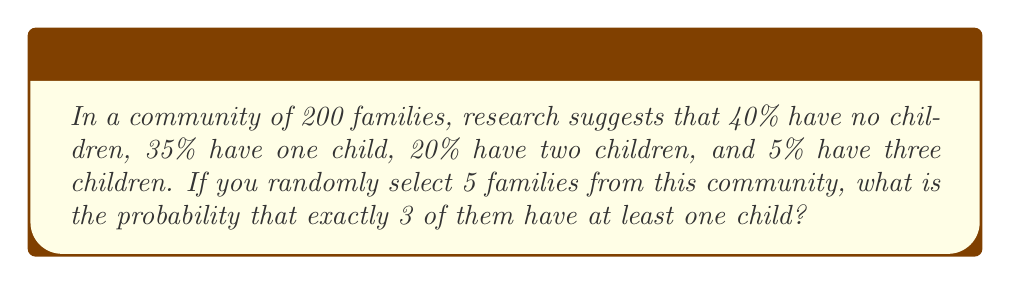Could you help me with this problem? Let's approach this step-by-step:

1) First, we need to calculate the probability of a family having at least one child:
   $P(\text{at least one child}) = 1 - P(\text{no children}) = 1 - 0.40 = 0.60$

2) Now, we can view this as a binomial probability problem. We're selecting 5 families, and we want exactly 3 of them to have at least one child.

3) The probability of success (having at least one child) on each selection is 0.60, and we want 3 successes out of 5 trials.

4) We can use the binomial probability formula:

   $$P(X = k) = \binom{n}{k} p^k (1-p)^{n-k}$$

   Where:
   $n = 5$ (total number of families selected)
   $k = 3$ (number of families we want with at least one child)
   $p = 0.60$ (probability of a family having at least one child)

5) Substituting these values:

   $$P(X = 3) = \binom{5}{3} (0.60)^3 (1-0.60)^{5-3}$$

6) Simplify:
   $$P(X = 3) = 10 \cdot (0.60)^3 \cdot (0.40)^2$$

7) Calculate:
   $$P(X = 3) = 10 \cdot 0.216 \cdot 0.16 = 0.3456$$

Therefore, the probability is approximately 0.3456 or 34.56%.
Answer: 0.3456 